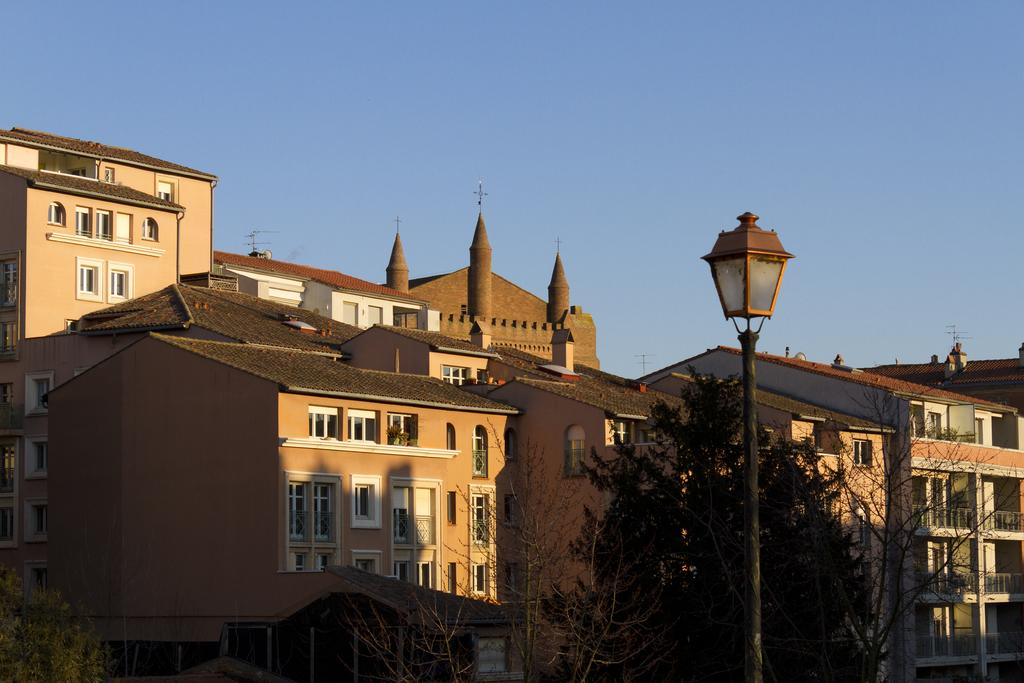What type of buildings are in the image? There are brown shed houses in the image. What can be seen in the front of the image? There is a black lamp post in the front of the image. What is visible at the top of the image? The sky is visible at the top of the image. What type of business is being conducted in the image? There is no indication of a business being conducted in the image; it primarily features brown shed houses and a black lamp post. What smell can be detected in the image? There is no information about smells in the image, as it only provides visual details. 